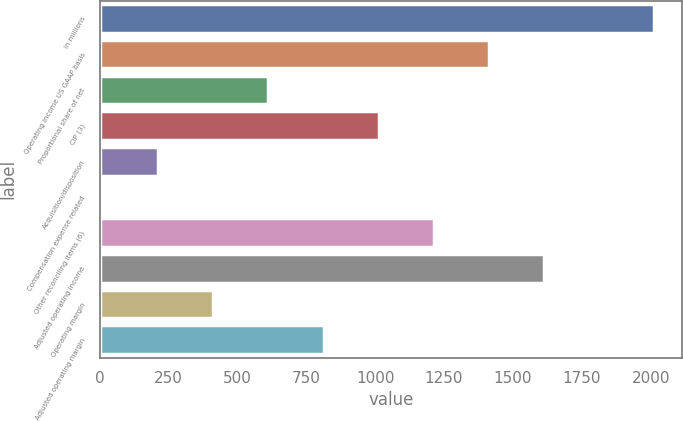<chart> <loc_0><loc_0><loc_500><loc_500><bar_chart><fcel>in millions<fcel>Operating income US GAAP basis<fcel>Proportional share of net<fcel>CIP (3)<fcel>Acquisition/disposition<fcel>Compensation expense related<fcel>Other reconciling items (6)<fcel>Adjusted operating income<fcel>Operating margin<fcel>Adjusted operating margin<nl><fcel>2014<fcel>1413.25<fcel>612.25<fcel>1012.75<fcel>211.75<fcel>11.5<fcel>1213<fcel>1613.5<fcel>412<fcel>812.5<nl></chart> 